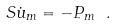<formula> <loc_0><loc_0><loc_500><loc_500>S \dot { u } _ { m } = - P _ { m } \ .</formula> 